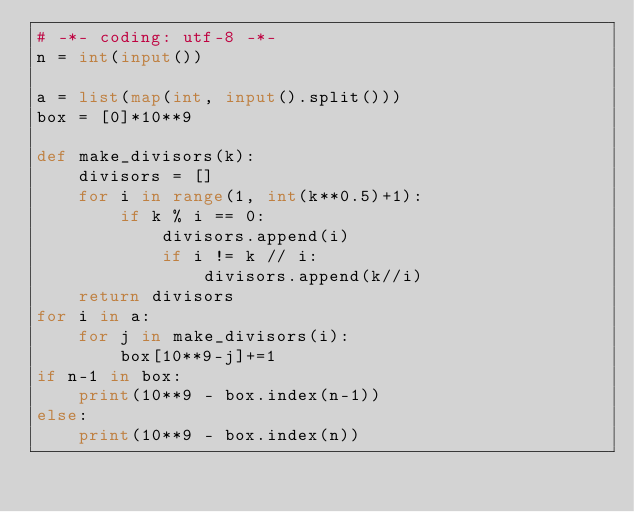Convert code to text. <code><loc_0><loc_0><loc_500><loc_500><_Python_># -*- coding: utf-8 -*-
n = int(input())

a = list(map(int, input().split()))
box = [0]*10**9

def make_divisors(k):
    divisors = []
    for i in range(1, int(k**0.5)+1):
        if k % i == 0:
            divisors.append(i)
            if i != k // i:
                divisors.append(k//i)
    return divisors
for i in a:
    for j in make_divisors(i):
        box[10**9-j]+=1 
if n-1 in box:
    print(10**9 - box.index(n-1))
else:
    print(10**9 - box.index(n))</code> 